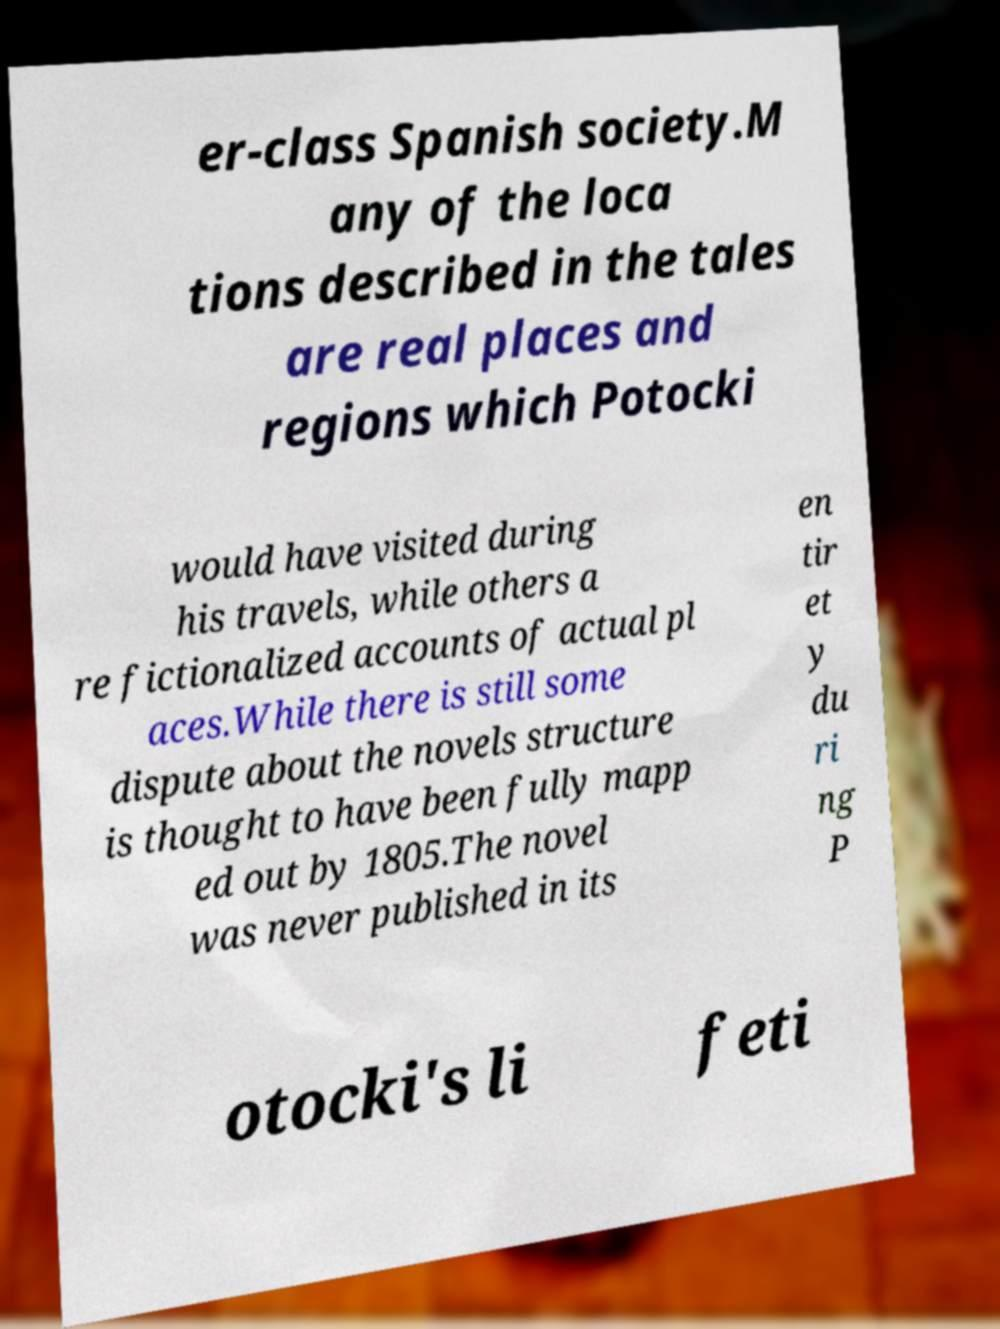Could you extract and type out the text from this image? er-class Spanish society.M any of the loca tions described in the tales are real places and regions which Potocki would have visited during his travels, while others a re fictionalized accounts of actual pl aces.While there is still some dispute about the novels structure is thought to have been fully mapp ed out by 1805.The novel was never published in its en tir et y du ri ng P otocki's li feti 